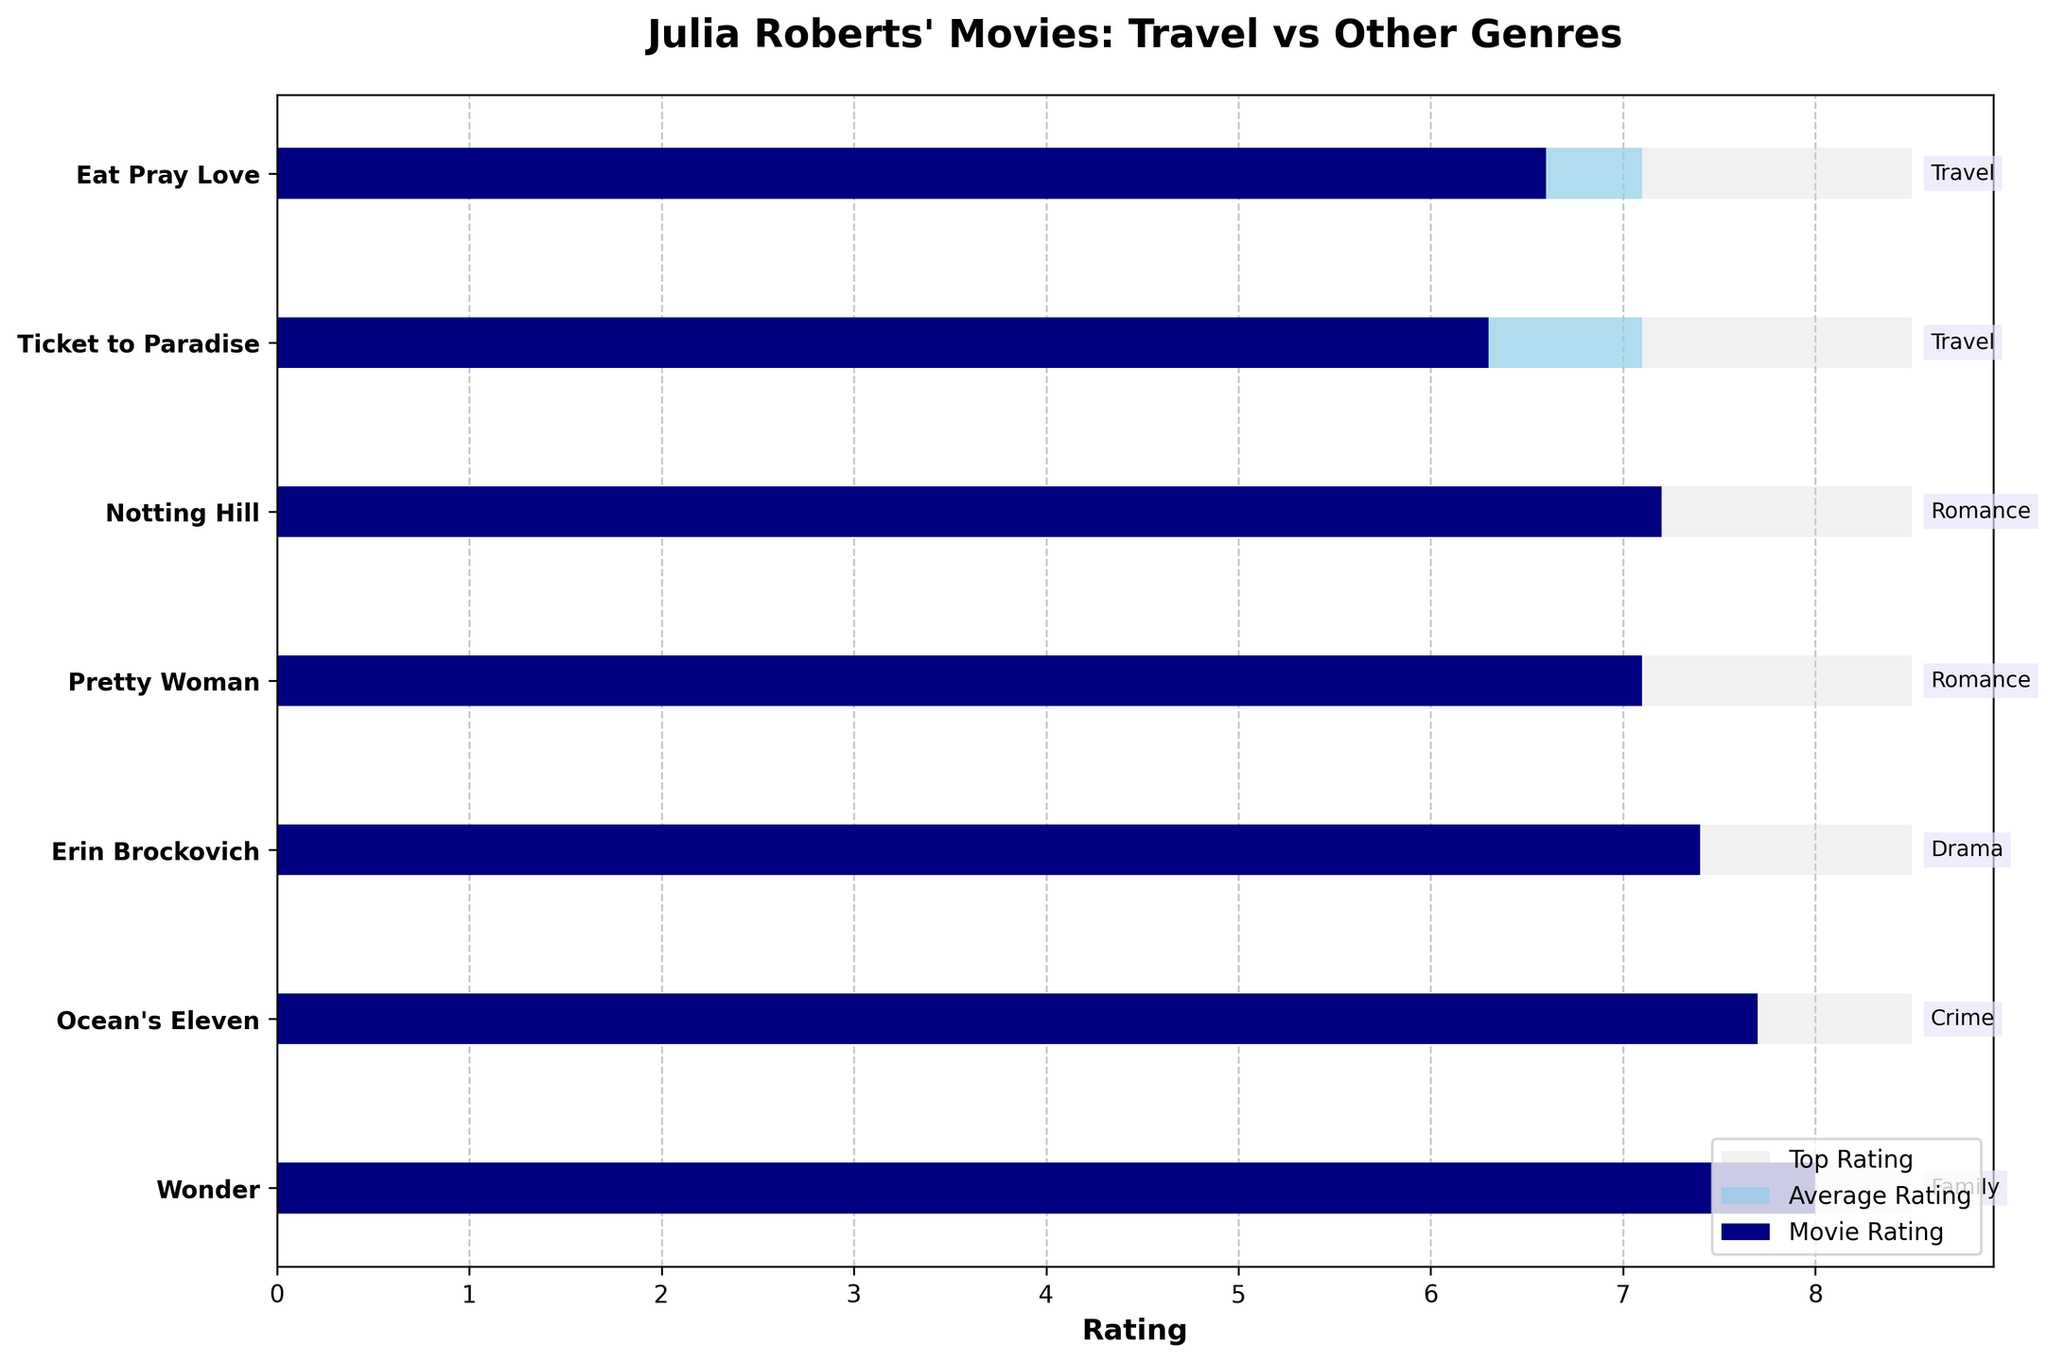What is the title of the figure? The title of the figure is generally located at the top of the chart and is intended to give an overview of what the chart represents. In this case, the title clearly states the focus on Julia Roberts' movies and their comparison between travel-themed films and other genres.
Answer: Julia Roberts' Movies: Travel vs Other Genres How many movies are compared in the figure? The number of movies can be determined by counting the y-ticks, each of which represents a movie on the y-axis.
Answer: 7 Which movie has the highest rating among the listed films? The highest rating can be identified by looking for the bar with the greatest length representing the "Movie Rating" category. Wonder stands out as it has a rating of 8.0, which is visually higher than the others.
Answer: Wonder How does the rating of "Eat Pray Love" compare to the average rating? To compare, locate the bar for "Eat Pray Love" and observe its length relative to the average rating bar. The rating for "Eat Pray Love" is 6.6, while the average rating bar is longer at 7.1.
Answer: Less than the average What genre has the most movies listed in the figure? Count the genre labels next to each movie title to identify which genre is mentioned the most. Both "Romance" and "Travel" have two movies each.
Answer: Romance and Travel (tie) Which genre does the movie with the highest rating belong to? Identify the movie with the highest rating, which is Wonder with a rating of 8.0, and then look at the genre label next to it.
Answer: Family What is the difference between Julia Roberts' highest rated travel-themed movie and her highest rated movie overall? Compare the rating of the highest-rated travel-themed movie (Eat Pray Love - 6.6) with the highest-rated movie (Wonder - 8.0). The difference is calculated as 8.0 - 6.6.
Answer: 1.4 How do the average ratings for Julia Roberts' movies compare to the top ratings presented? The average rating bar consistently represents a rating of 7.1 for all movies, while the top rating bar tops at 8.5. This consistency can be seen across all entries.
Answer: Average ratings are lower Is "Erin Brockovich" rated higher or lower than "Pretty Woman"? To compare their ratings, look at the length of the "Movie Rating" bars. Erin Brockovich is 7.4, which is higher than Pretty Woman's 7.1.
Answer: Higher 